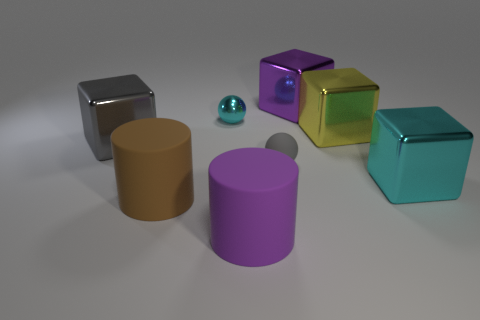How big is the block that is in front of the yellow block and to the right of the small gray matte sphere?
Offer a very short reply. Large. Are there any blue cubes?
Your response must be concise. No. How many other objects are there of the same size as the gray metal block?
Provide a succinct answer. 5. Does the tiny sphere behind the large yellow metal cube have the same color as the large cube in front of the gray shiny block?
Your answer should be very brief. Yes. The cyan shiny object that is the same shape as the gray matte object is what size?
Your answer should be very brief. Small. Does the tiny thing in front of the gray metallic thing have the same material as the cube that is left of the purple metal block?
Make the answer very short. No. What number of matte objects are big red cylinders or spheres?
Offer a very short reply. 1. The large thing that is on the left side of the large rubber object that is behind the cylinder that is on the right side of the large brown cylinder is made of what material?
Your answer should be very brief. Metal. There is a big object that is behind the tiny cyan shiny object; is its shape the same as the large shiny object that is to the left of the small cyan sphere?
Provide a succinct answer. Yes. The big cube that is on the left side of the big rubber thing right of the cyan sphere is what color?
Your response must be concise. Gray. 